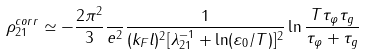Convert formula to latex. <formula><loc_0><loc_0><loc_500><loc_500>\rho ^ { c o r r } _ { 2 1 } \simeq - \frac { 2 \pi ^ { 2 } } { 3 } \frac { } { e ^ { 2 } } \frac { 1 } { ( k _ { F } l ) ^ { 2 } [ \lambda ^ { - 1 } _ { 2 1 } + \ln ( \varepsilon _ { 0 } / T ) ] ^ { 2 } } \ln \frac { T \tau _ { \varphi } \tau _ { g } } { \tau _ { \varphi } + \tau _ { g } }</formula> 